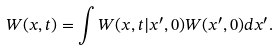Convert formula to latex. <formula><loc_0><loc_0><loc_500><loc_500>W ( { x } , t ) = \int W ( { x } , t | { x ^ { \prime } } , 0 ) W ( { x ^ { \prime } } , 0 ) d { x ^ { \prime } } .</formula> 